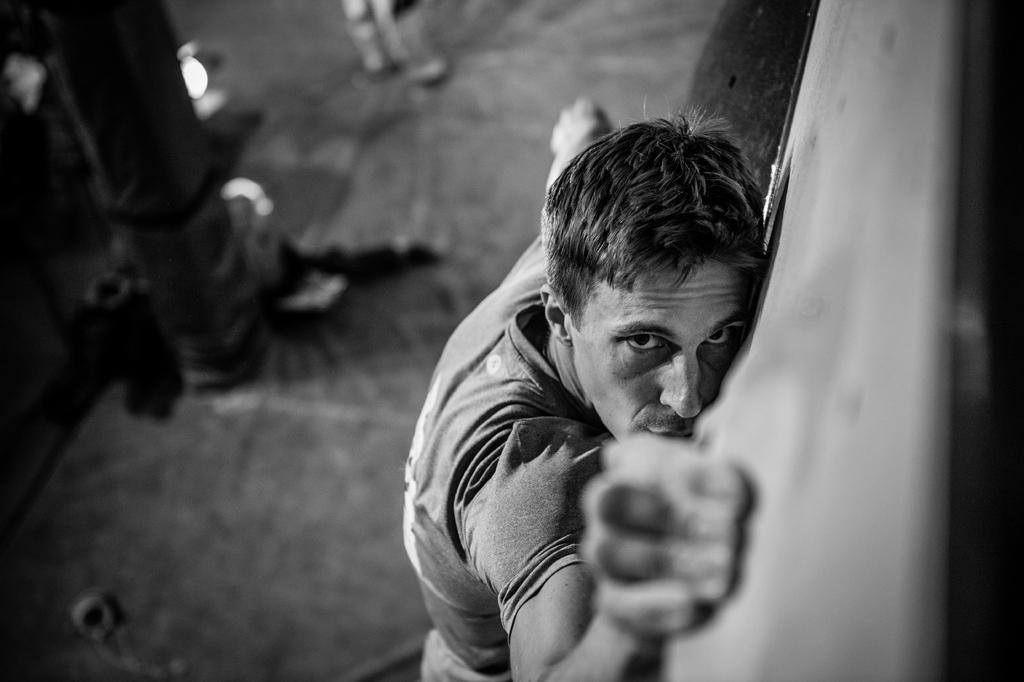Can you describe this image briefly? In the image in the center, we can see one person standing. In the background there is a pole and a few other objects. 